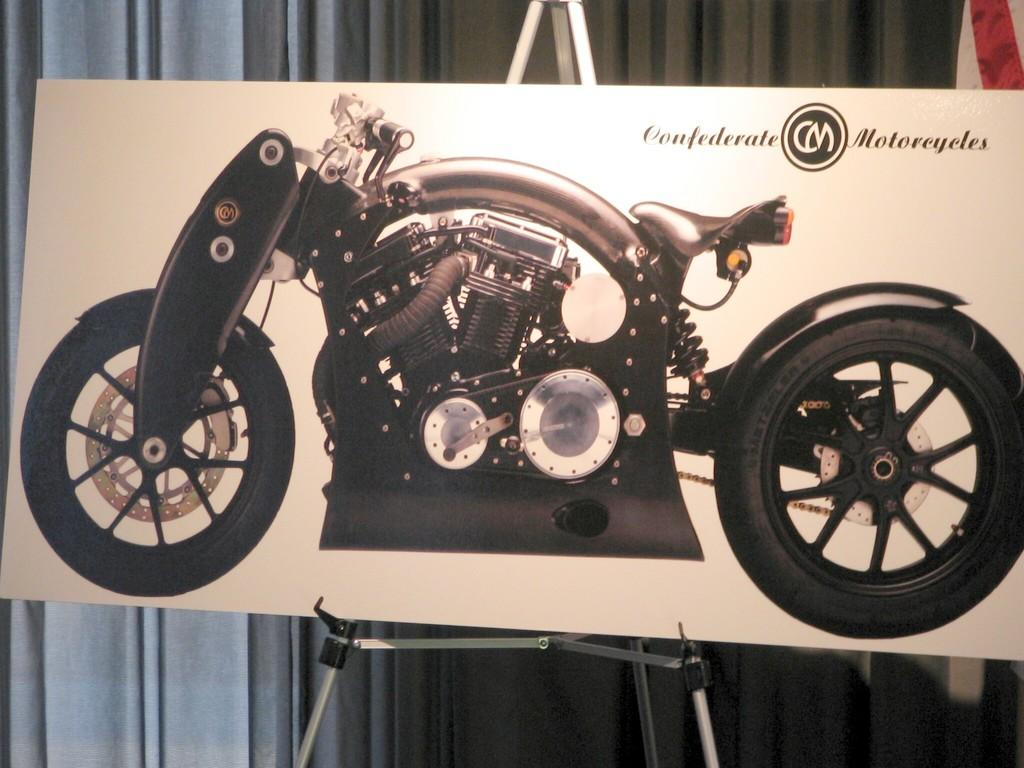What is the main object in the image? There is a board in the image. How is the board positioned? The board is placed on a stand. What is depicted on the board? The board has an image of a bike. Where is the text located on the board? There is text written in the right top corner of the board. What can be seen in the background of the image? There are curtains in the background of the image. How many jellyfish are swimming in the image? There are no jellyfish present in the image. What is the girl doing in the image? There is no girl present in the image. 